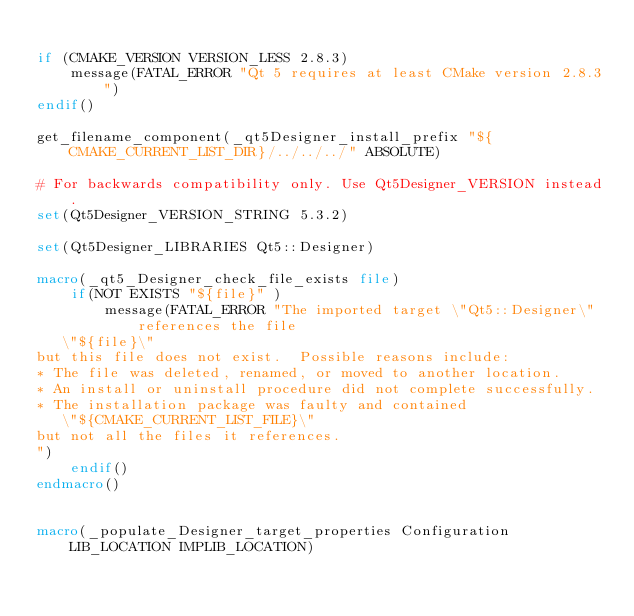<code> <loc_0><loc_0><loc_500><loc_500><_CMake_>
if (CMAKE_VERSION VERSION_LESS 2.8.3)
    message(FATAL_ERROR "Qt 5 requires at least CMake version 2.8.3")
endif()

get_filename_component(_qt5Designer_install_prefix "${CMAKE_CURRENT_LIST_DIR}/../../../" ABSOLUTE)

# For backwards compatibility only. Use Qt5Designer_VERSION instead.
set(Qt5Designer_VERSION_STRING 5.3.2)

set(Qt5Designer_LIBRARIES Qt5::Designer)

macro(_qt5_Designer_check_file_exists file)
    if(NOT EXISTS "${file}" )
        message(FATAL_ERROR "The imported target \"Qt5::Designer\" references the file
   \"${file}\"
but this file does not exist.  Possible reasons include:
* The file was deleted, renamed, or moved to another location.
* An install or uninstall procedure did not complete successfully.
* The installation package was faulty and contained
   \"${CMAKE_CURRENT_LIST_FILE}\"
but not all the files it references.
")
    endif()
endmacro()


macro(_populate_Designer_target_properties Configuration LIB_LOCATION IMPLIB_LOCATION)</code> 